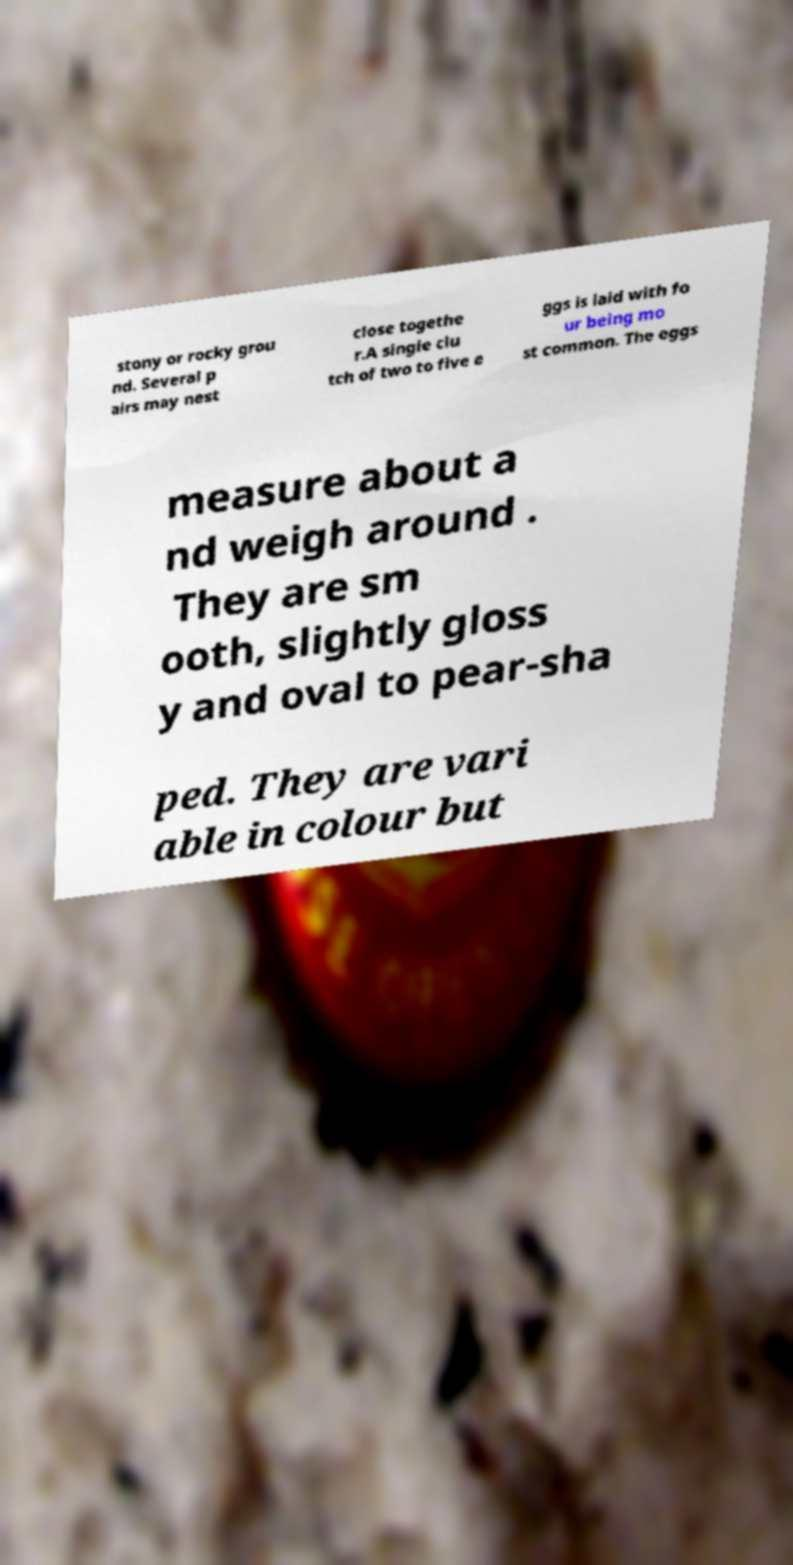Can you accurately transcribe the text from the provided image for me? stony or rocky grou nd. Several p airs may nest close togethe r.A single clu tch of two to five e ggs is laid with fo ur being mo st common. The eggs measure about a nd weigh around . They are sm ooth, slightly gloss y and oval to pear-sha ped. They are vari able in colour but 